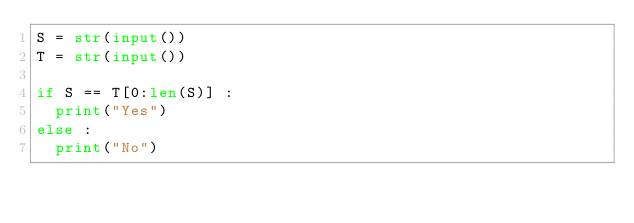<code> <loc_0><loc_0><loc_500><loc_500><_Python_>S = str(input())
T = str(input())

if S == T[0:len(S)] :
  print("Yes")
else :
  print("No")</code> 